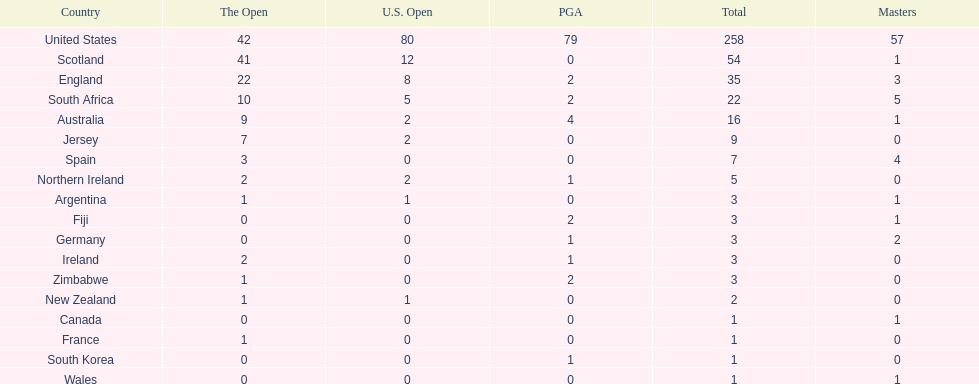How many total championships does spain have? 7. 